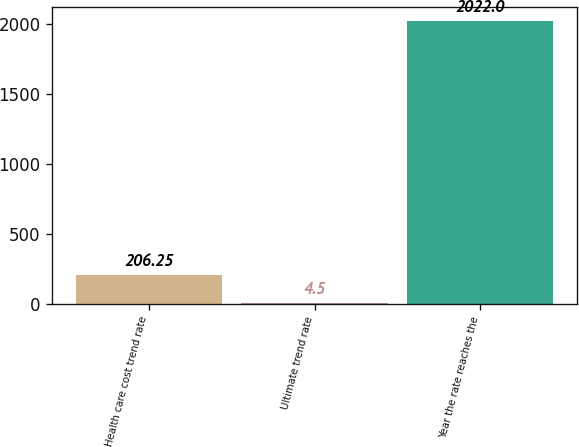Convert chart. <chart><loc_0><loc_0><loc_500><loc_500><bar_chart><fcel>Health care cost trend rate<fcel>Ultimate trend rate<fcel>Year the rate reaches the<nl><fcel>206.25<fcel>4.5<fcel>2022<nl></chart> 